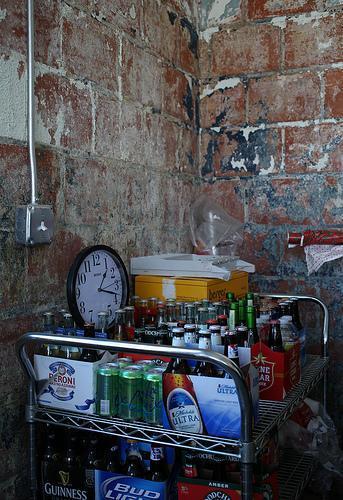How many of the beer six-packs are cans?
Give a very brief answer. 1. 